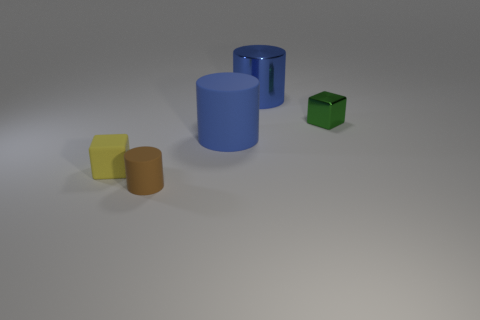Add 4 yellow matte things. How many objects exist? 9 Subtract all cylinders. How many objects are left? 2 Add 3 tiny cylinders. How many tiny cylinders exist? 4 Subtract 1 green cubes. How many objects are left? 4 Subtract all yellow matte objects. Subtract all metal cylinders. How many objects are left? 3 Add 4 brown rubber cylinders. How many brown rubber cylinders are left? 5 